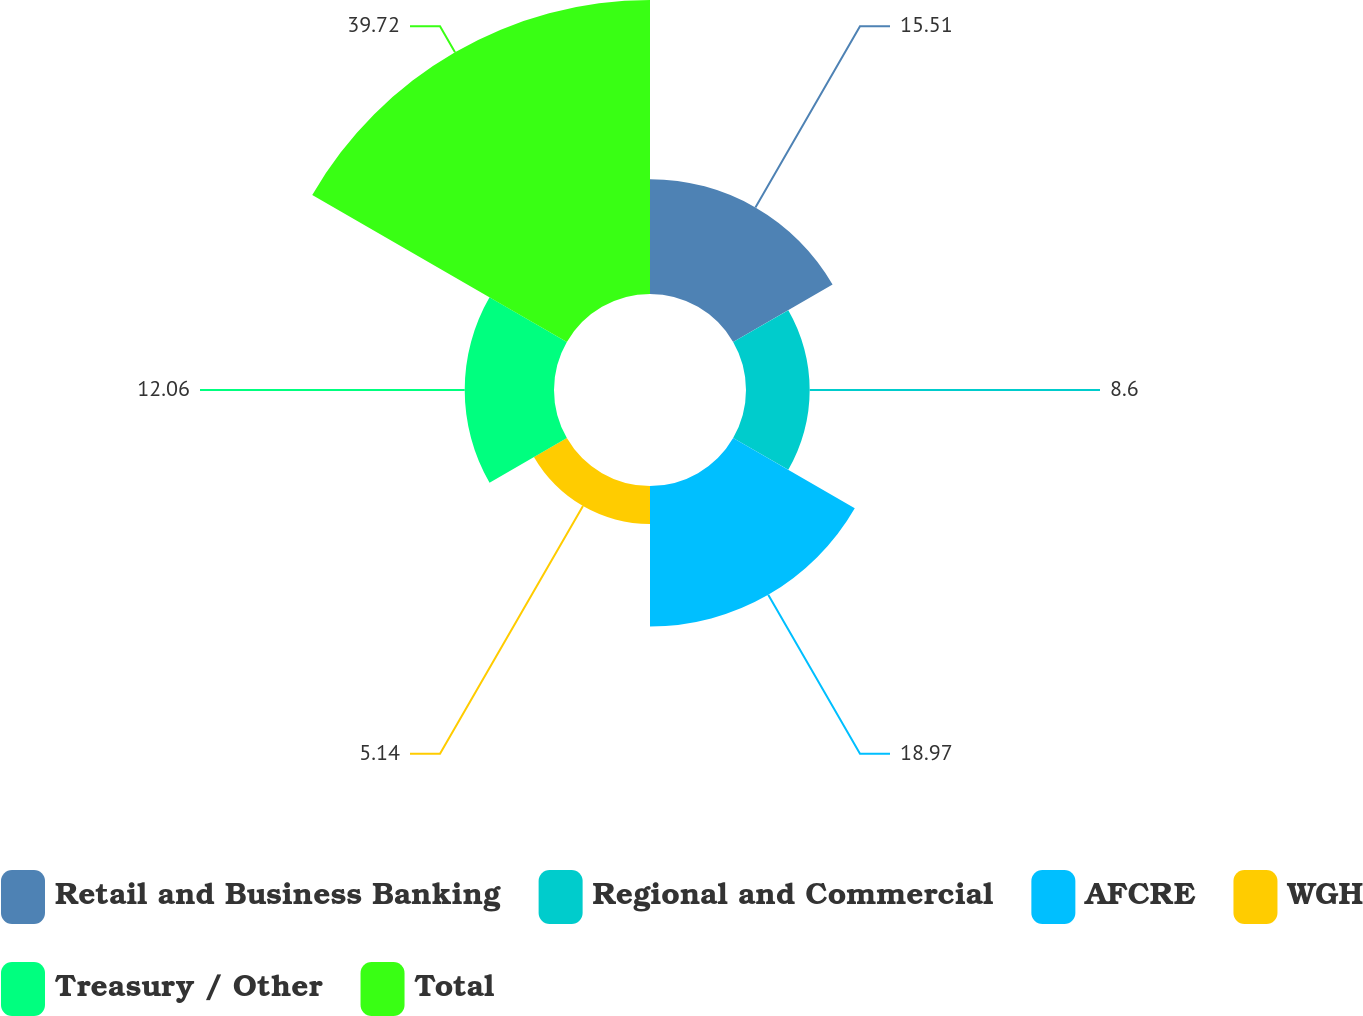Convert chart. <chart><loc_0><loc_0><loc_500><loc_500><pie_chart><fcel>Retail and Business Banking<fcel>Regional and Commercial<fcel>AFCRE<fcel>WGH<fcel>Treasury / Other<fcel>Total<nl><fcel>15.51%<fcel>8.6%<fcel>18.97%<fcel>5.14%<fcel>12.06%<fcel>39.71%<nl></chart> 